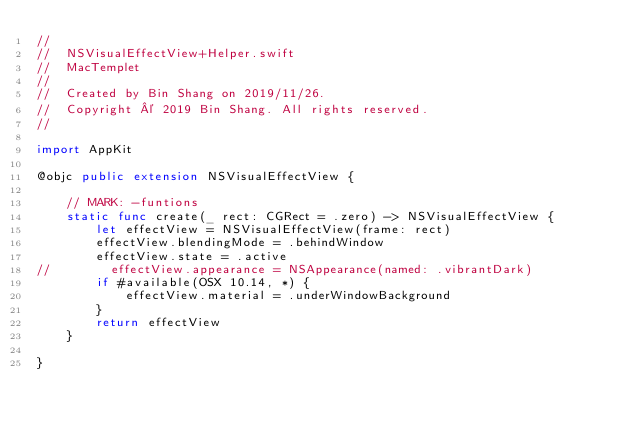Convert code to text. <code><loc_0><loc_0><loc_500><loc_500><_Swift_>//
//  NSVisualEffectView+Helper.swift
//  MacTemplet
//
//  Created by Bin Shang on 2019/11/26.
//  Copyright © 2019 Bin Shang. All rights reserved.
//

import AppKit

@objc public extension NSVisualEffectView {
        
    // MARK: -funtions
    static func create(_ rect: CGRect = .zero) -> NSVisualEffectView {
        let effectView = NSVisualEffectView(frame: rect)
        effectView.blendingMode = .behindWindow
        effectView.state = .active
//        effectView.appearance = NSAppearance(named: .vibrantDark)
        if #available(OSX 10.14, *) {
            effectView.material = .underWindowBackground
        }
        return effectView
    }
    
}
</code> 